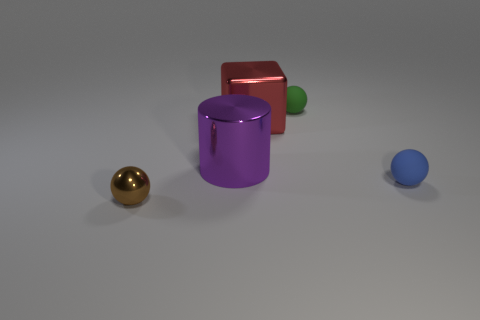Imagine if these objects represented members of a family, can you describe their personalities based on their appearance? If these objects were family members, the golden sphere could be seen as the glamorous, attention-seeking one, bright and shiny. The purple cylinder might be the sophisticated, cool-headed intellectual. The green sphere appears youthful and energetic, the red cube as the strong, stable, and reliable one, and the small blue sphere as the playful, innocent youngest member of the family. 